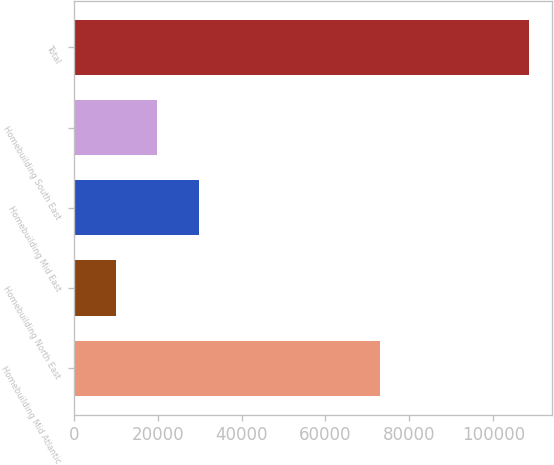<chart> <loc_0><loc_0><loc_500><loc_500><bar_chart><fcel>Homebuilding Mid Atlantic<fcel>Homebuilding North East<fcel>Homebuilding Mid East<fcel>Homebuilding South East<fcel>Total<nl><fcel>73042<fcel>10081<fcel>29766.6<fcel>19923.8<fcel>108509<nl></chart> 